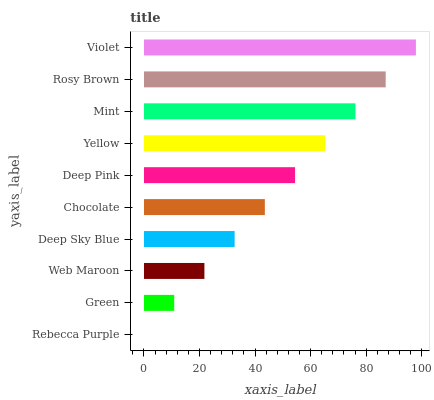Is Rebecca Purple the minimum?
Answer yes or no. Yes. Is Violet the maximum?
Answer yes or no. Yes. Is Green the minimum?
Answer yes or no. No. Is Green the maximum?
Answer yes or no. No. Is Green greater than Rebecca Purple?
Answer yes or no. Yes. Is Rebecca Purple less than Green?
Answer yes or no. Yes. Is Rebecca Purple greater than Green?
Answer yes or no. No. Is Green less than Rebecca Purple?
Answer yes or no. No. Is Deep Pink the high median?
Answer yes or no. Yes. Is Chocolate the low median?
Answer yes or no. Yes. Is Deep Sky Blue the high median?
Answer yes or no. No. Is Web Maroon the low median?
Answer yes or no. No. 